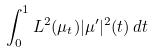<formula> <loc_0><loc_0><loc_500><loc_500>\int _ { 0 } ^ { 1 } L ^ { 2 } ( \mu _ { t } ) | \mu ^ { \prime } | ^ { 2 } ( t ) \, d t</formula> 